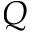<formula> <loc_0><loc_0><loc_500><loc_500>Q</formula> 